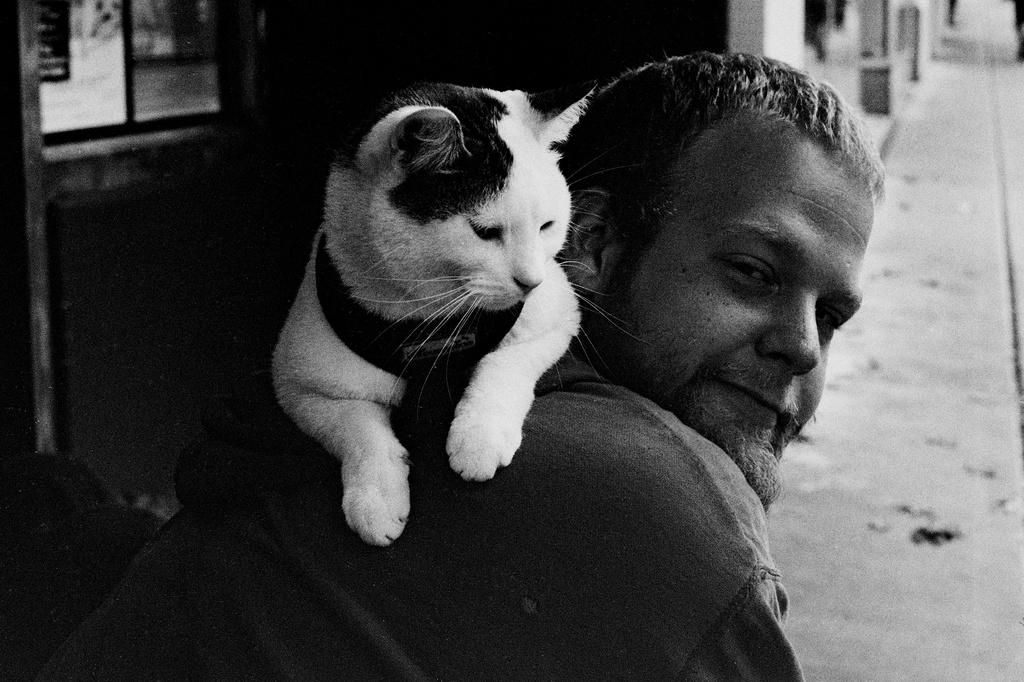What is the main subject of the image? There is a person in the image. What is the person doing in the image? The person is carrying a cat on their back. What type of rhythm is the person creating with the chalk in the image? There is no chalk present in the image, and therefore no rhythm can be created with it. 